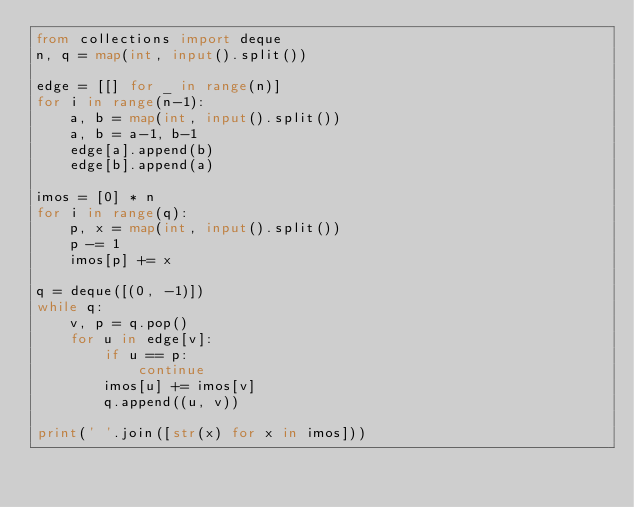<code> <loc_0><loc_0><loc_500><loc_500><_Python_>from collections import deque
n, q = map(int, input().split())

edge = [[] for _ in range(n)]
for i in range(n-1):
    a, b = map(int, input().split())
    a, b = a-1, b-1
    edge[a].append(b)
    edge[b].append(a)

imos = [0] * n
for i in range(q):
    p, x = map(int, input().split())
    p -= 1
    imos[p] += x

q = deque([(0, -1)])
while q:
    v, p = q.pop()
    for u in edge[v]:
        if u == p:
            continue
        imos[u] += imos[v]
        q.append((u, v))

print(' '.join([str(x) for x in imos]))
</code> 